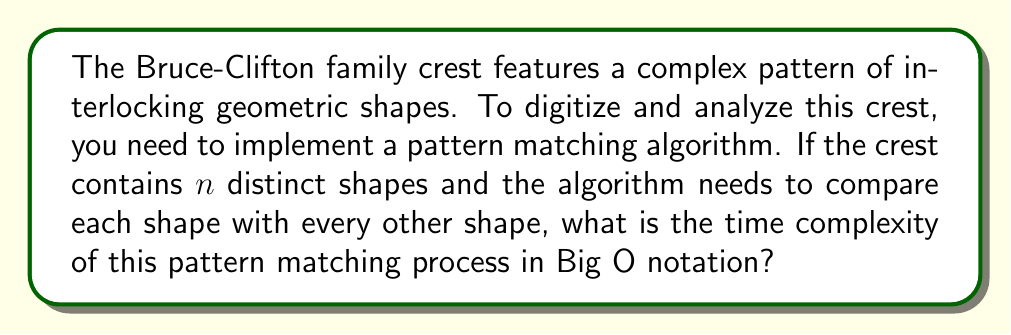Teach me how to tackle this problem. To solve this problem, let's break it down step-by-step:

1. We have $n$ distinct shapes in the family crest.

2. The pattern matching algorithm needs to compare each shape with every other shape. This means:
   - The first shape is compared with $(n-1)$ other shapes
   - The second shape is compared with $(n-2)$ other shapes
   - The third shape is compared with $(n-3)$ other shapes
   - And so on...

3. The total number of comparisons can be represented as:
   $$(n-1) + (n-2) + (n-3) + ... + 2 + 1$$

4. This is an arithmetic series with $(n-1)$ terms. The sum of an arithmetic series is given by:
   $$S = \frac{n(a_1 + a_n)}{2}$$
   Where $n$ is the number of terms, $a_1$ is the first term, and $a_n$ is the last term.

5. In our case:
   - Number of terms = $(n-1)$
   - First term $a_1 = (n-1)$
   - Last term $a_n = 1$

6. Substituting these values:
   $$S = \frac{(n-1)((n-1) + 1)}{2} = \frac{(n-1)n}{2}$$

7. Expanding this:
   $$\frac{n^2 - n}{2}$$

8. In Big O notation, we only consider the highest order term and drop constants. Therefore, the time complexity is $O(n^2)$.
Answer: $O(n^2)$ 